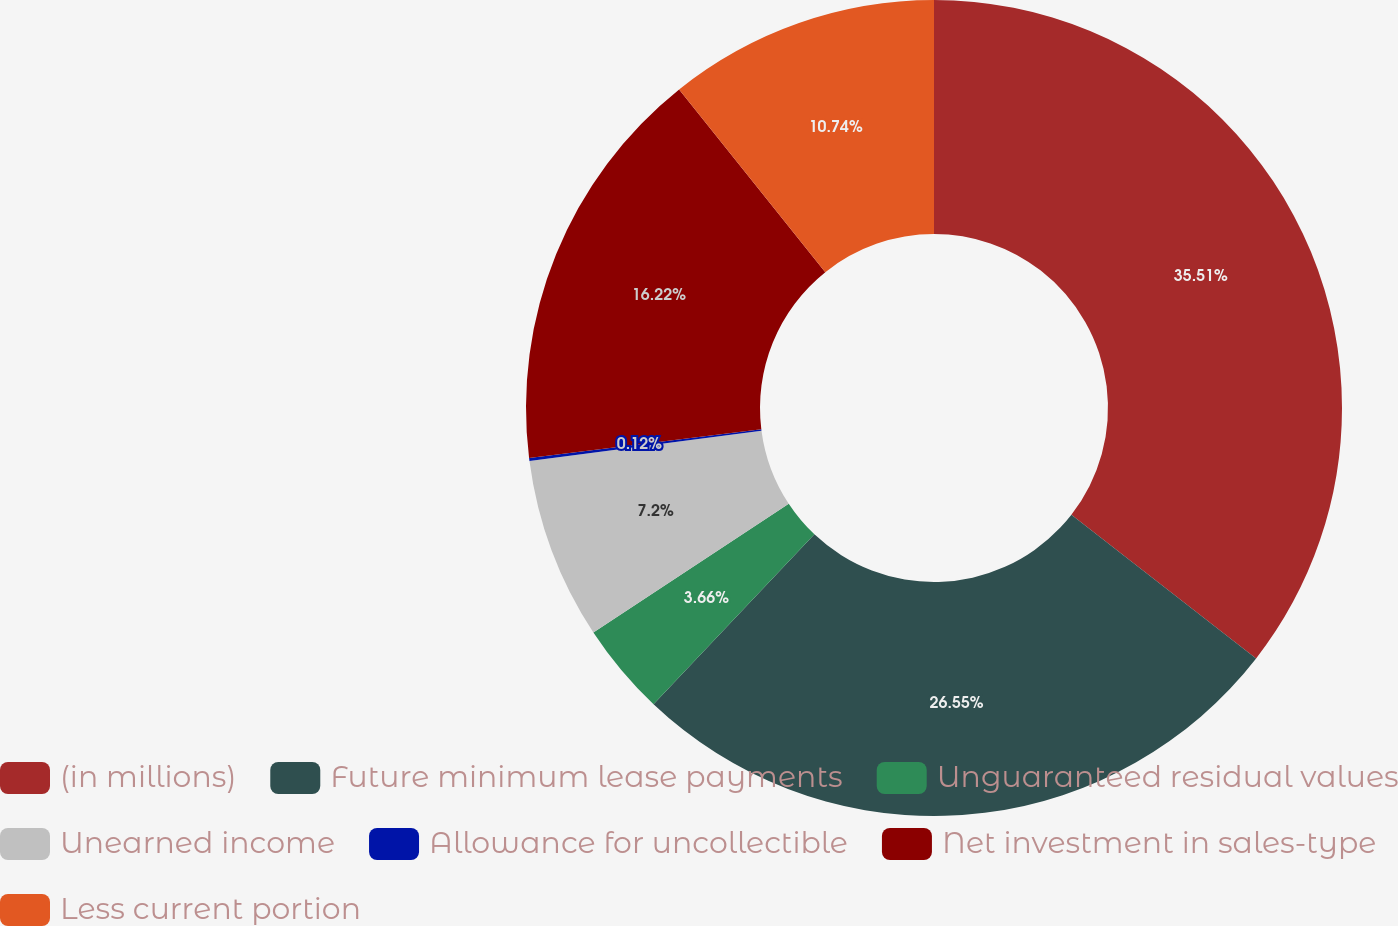Convert chart. <chart><loc_0><loc_0><loc_500><loc_500><pie_chart><fcel>(in millions)<fcel>Future minimum lease payments<fcel>Unguaranteed residual values<fcel>Unearned income<fcel>Allowance for uncollectible<fcel>Net investment in sales-type<fcel>Less current portion<nl><fcel>35.52%<fcel>26.55%<fcel>3.66%<fcel>7.2%<fcel>0.12%<fcel>16.22%<fcel>10.74%<nl></chart> 